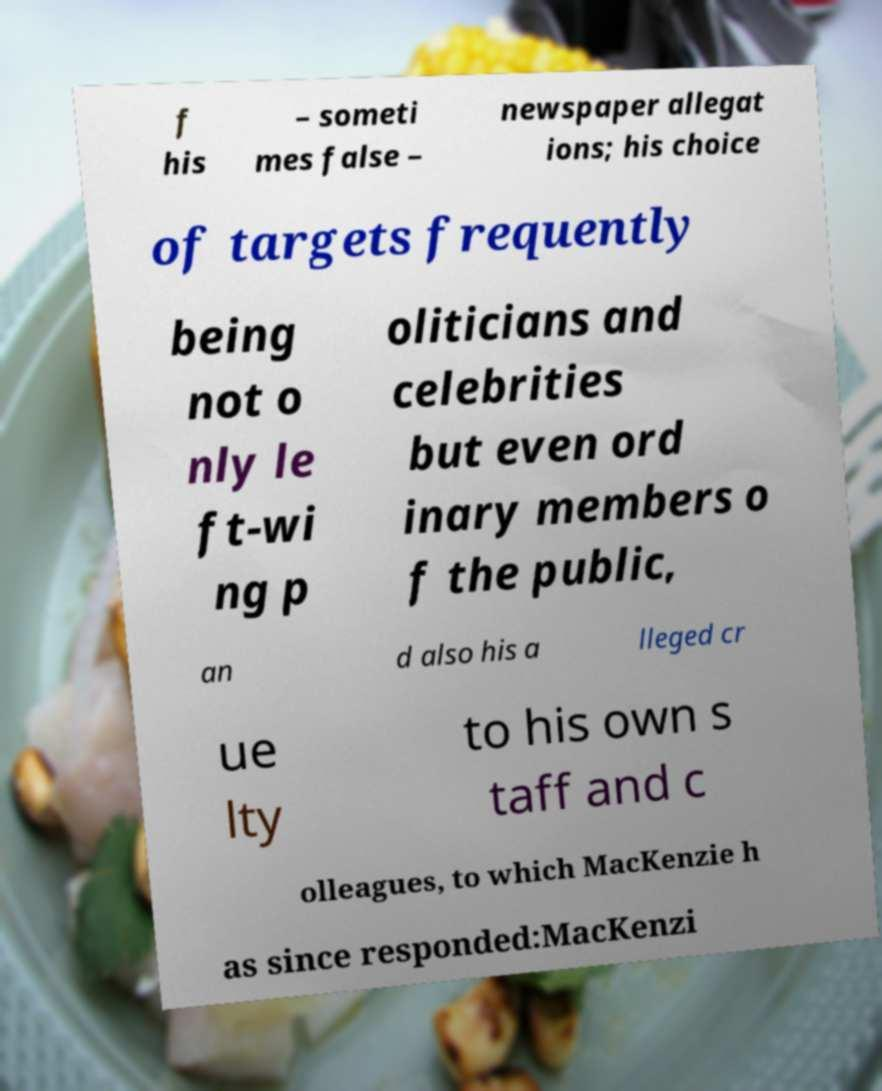I need the written content from this picture converted into text. Can you do that? f his – someti mes false – newspaper allegat ions; his choice of targets frequently being not o nly le ft-wi ng p oliticians and celebrities but even ord inary members o f the public, an d also his a lleged cr ue lty to his own s taff and c olleagues, to which MacKenzie h as since responded:MacKenzi 